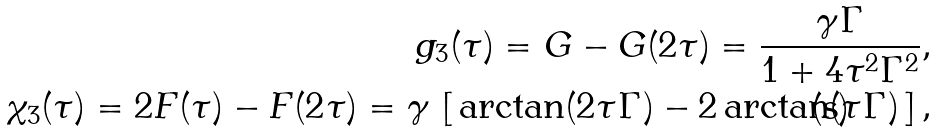Convert formula to latex. <formula><loc_0><loc_0><loc_500><loc_500>g _ { 3 } ( \tau ) = G - G ( 2 \tau ) = \frac { \gamma \Gamma } { 1 + 4 \tau ^ { 2 } \Gamma ^ { 2 } } , \\ \chi _ { 3 } ( \tau ) = 2 F ( \tau ) - F ( 2 \tau ) = \gamma \, \left [ \, \arctan ( 2 \tau \Gamma ) - 2 \arctan ( \tau \Gamma ) \, \right ] ,</formula> 